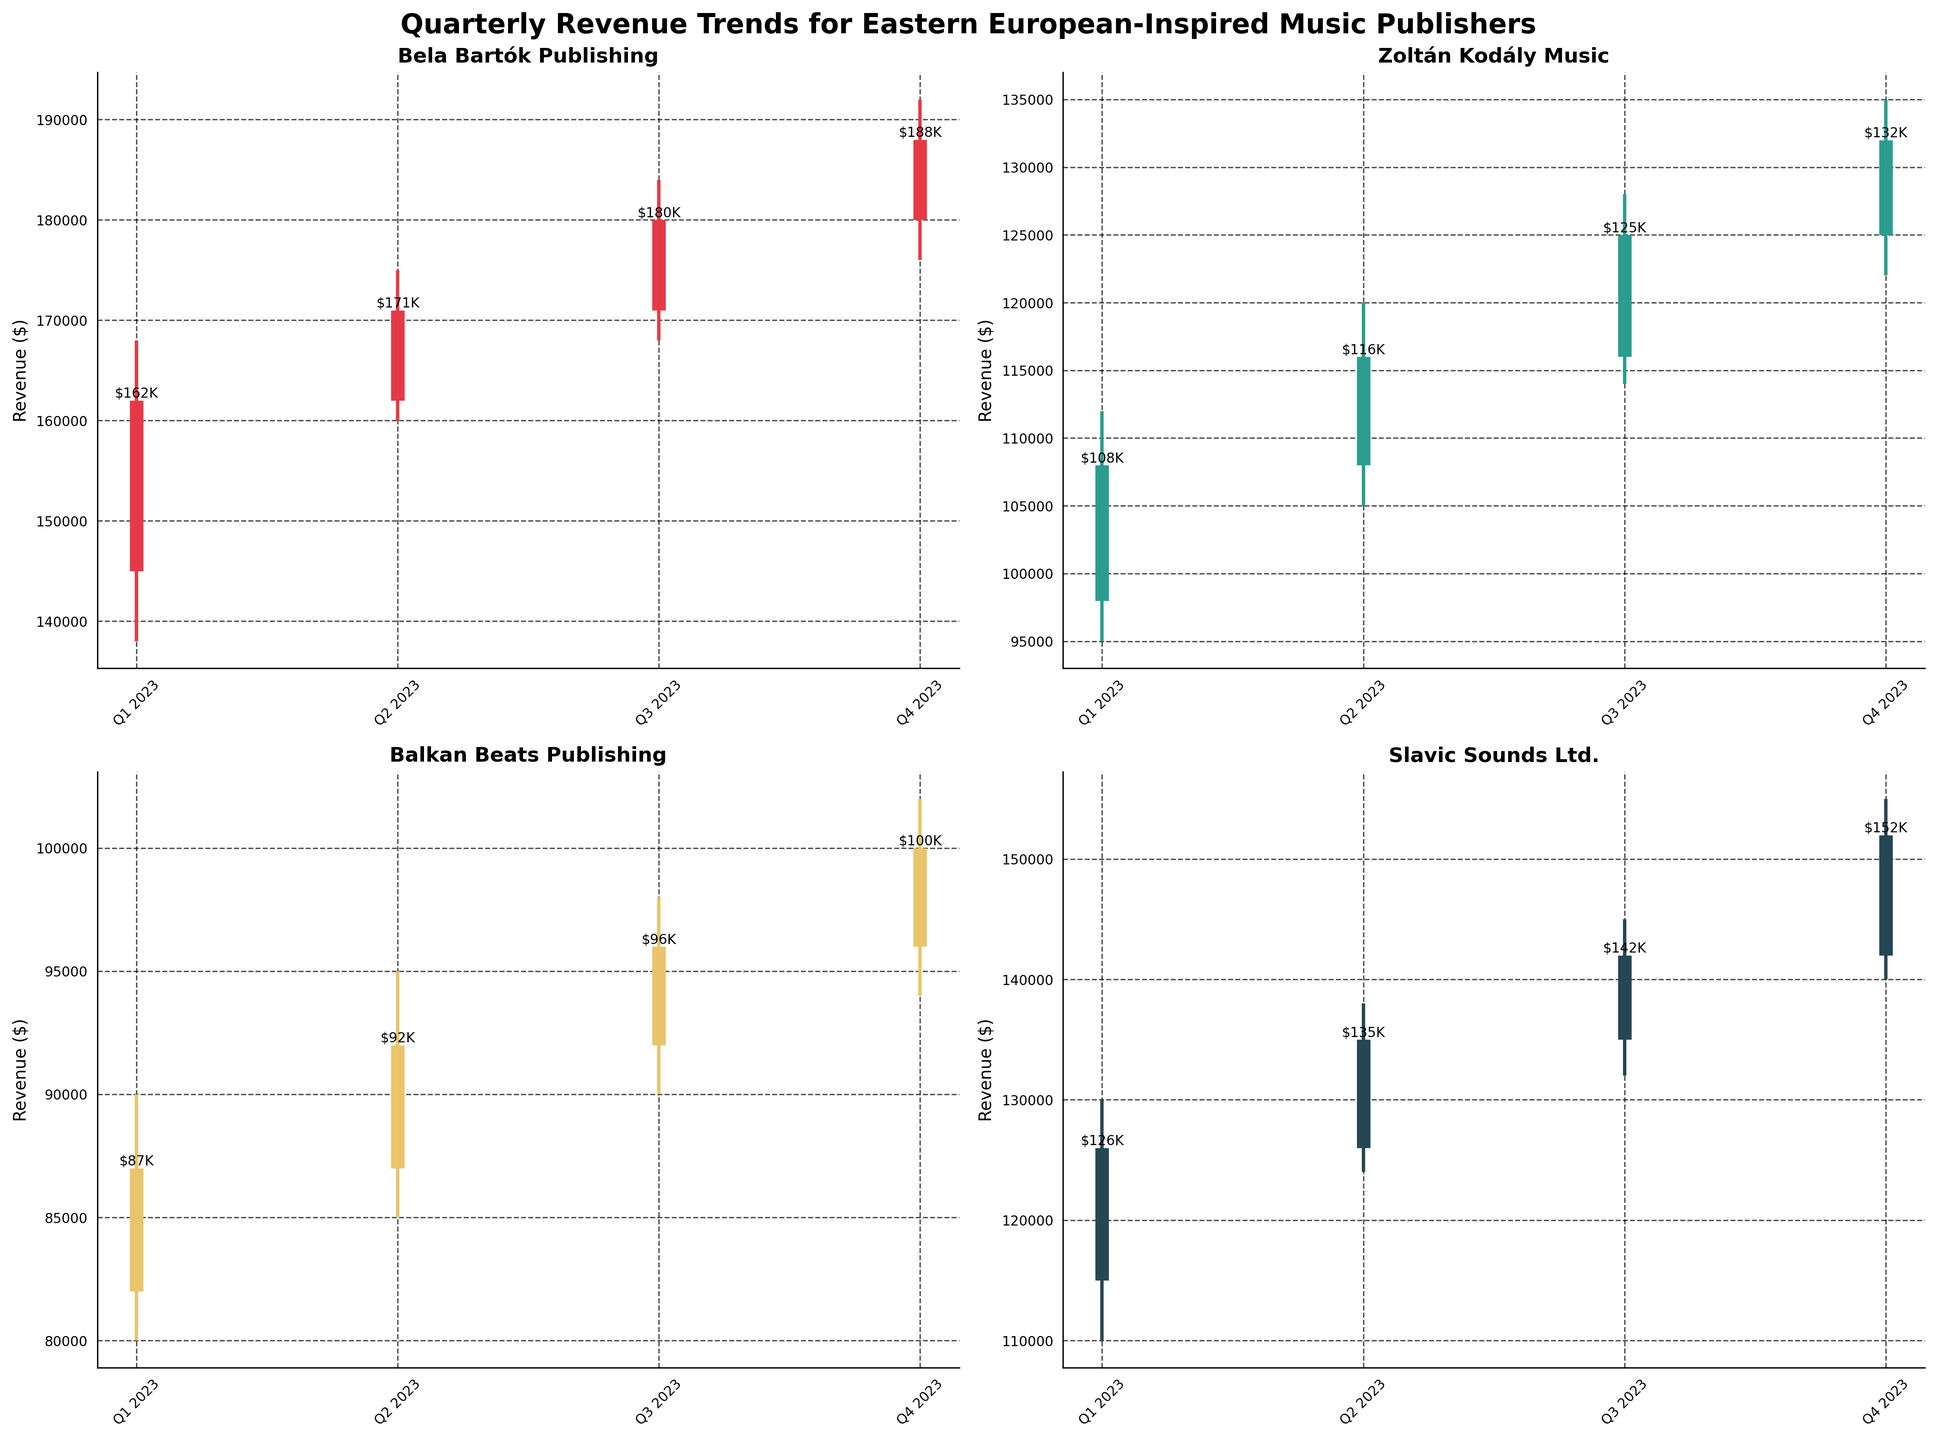1. What company had the highest closing revenue in Q4 2023? The graph for "Bela Bartók Publishing" shows the highest closing figure for Q4 2023, which is $188,000. This value is plotted as the top-most in the closing revenue lines among all companies for that quarter.
Answer: Bela Bartók Publishing 2. How many total data points are shown for each company? Each company has data points for four quarters (Q1, Q2, Q3, Q4 of 2023). This can be observed from the consistent pattern of four vertical lines plotted for each company.
Answer: 4 3. Comparing Q1 and Q4 2023, which company had the most significant growth in closing revenue? From Q1 to Q4 2023, "Bela Bartók Publishing" increased from $162,000 to $188,000, showing the most significant growth of $26,000. This is higher than the growth observed in the closing revenues of other companies.
Answer: Bela Bartók Publishing 4. What was the closing revenue of "Zoltán Kodály Music" in Q3 2023, and how does it compare to "Balkan Beats Publishing" in the same quarter? "Zoltán Kodály Music" had a closing revenue of $125,000 in Q3 2023, while "Balkan Beats Publishing" closed with $96,000 in the same quarter. Comparing these values, "Zoltán Kodály Music" had a higher closing revenue.
Answer: $125,000; higher 5. What is the maximum high value recorded for "Slavic Sounds Ltd."? The highest high value for "Slavic Sounds Ltd." can be found at $155,000, as plotted by the topmost part of the vertical line in Q4 2023 for this company.
Answer: $155,000 6. Which company showed the least volatility in Q2 2023, and how was this determined? "Bela Bartók Publishing" showed the least volatility in Q2 2023 as the range between its high and low values ($175,000 - $160,000 = $15,000) is the smallest among all companies for that quarter.
Answer: Bela Bartók Publishing 7. What does the plot title indicate about the companies represented in the chart? The title "Quarterly Revenue Trends for Eastern European-Inspired Music Publishers" indicates that the companies represented specialize in music publishing with a focus on Eastern European-inspired works.
Answer: Eastern European-Inspired Music Publishers 8. Compare the highest revenue achieved by "Balkan Beats Publishing" with the lowest revenue of "Slavic Sounds Ltd." in the entire year. The highest revenue for "Balkan Beats Publishing" is $102,000 in Q4 2023, and the lowest for "Slavic Sounds Ltd." is $110,000 in Q1 2023. The lowest value of "Slavic Sounds Ltd." is still higher than the highest revenue of "Balkan Beats Publishing".
Answer: $102,000 vs $110,000; Slavic Sounds Ltd. is higher 